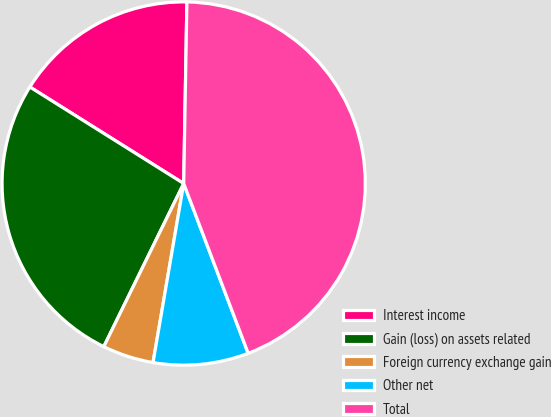<chart> <loc_0><loc_0><loc_500><loc_500><pie_chart><fcel>Interest income<fcel>Gain (loss) on assets related<fcel>Foreign currency exchange gain<fcel>Other net<fcel>Total<nl><fcel>16.36%<fcel>26.67%<fcel>4.55%<fcel>8.48%<fcel>43.94%<nl></chart> 